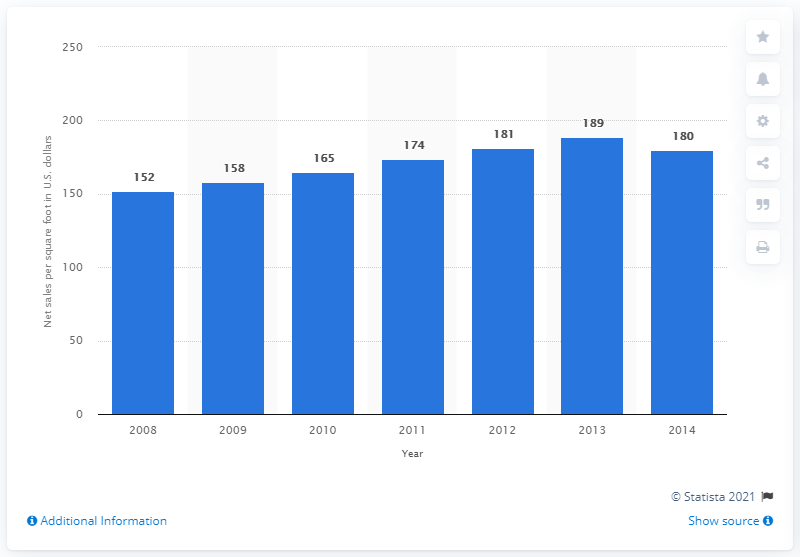Point out several critical features in this image. In the year 2012, the net sales per square foot of Family Dollar in the United States was 181. 